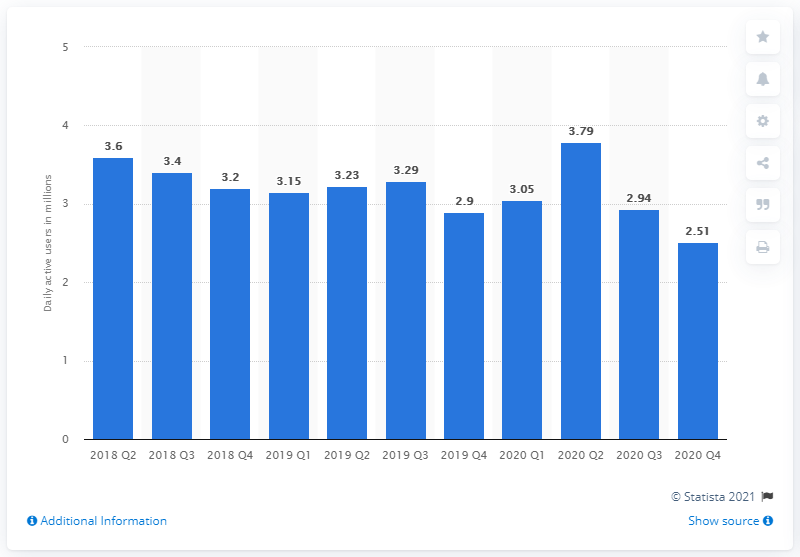List a handful of essential elements in this visual. In the fourth quarter of 2020, Glu Mobile had 2.51 daily active users. 